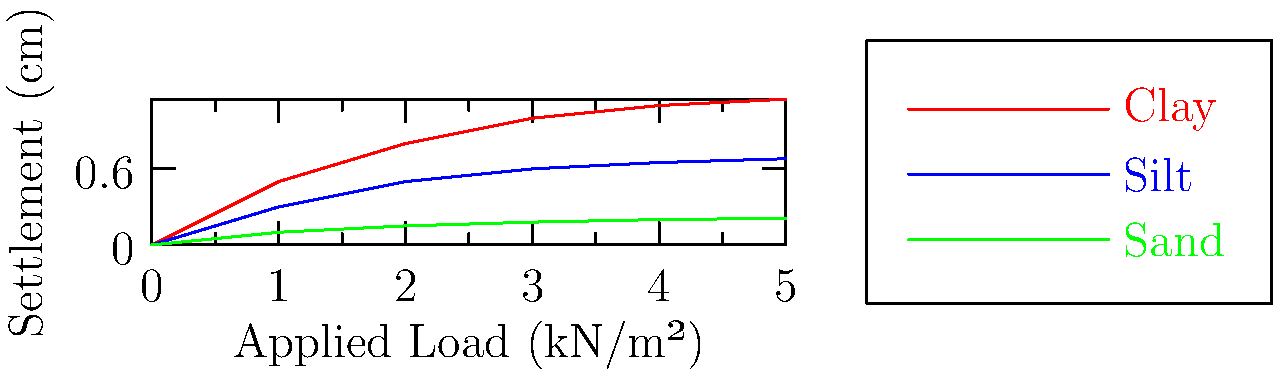A foundation is constructed on three different soil types: clay, silt, and sand. Based on the settlement curves shown in the graph, which soil type exhibits the highest settlement under an applied load of 3 kN/m²? Explain the factors contributing to the differences in settlement behavior among these soil types. To determine which soil type exhibits the highest settlement under an applied load of 3 kN/m², we need to analyze the graph and follow these steps:

1. Locate the applied load of 3 kN/m² on the x-axis.
2. Find the corresponding settlement values for each soil type at this load:
   - Clay (red line): approximately 1.0 cm
   - Silt (blue line): approximately 0.6 cm
   - Sand (green line): approximately 0.18 cm

3. Compare the settlement values:
   Clay (1.0 cm) > Silt (0.6 cm) > Sand (0.18 cm)

Therefore, clay exhibits the highest settlement under an applied load of 3 kN/m².

Factors contributing to the differences in settlement behavior:

1. Soil compressibility: Clay has the highest compressibility due to its plate-like particle structure and high water content, leading to more significant settlement.

2. Void ratio: Clay typically has a higher initial void ratio compared to silt and sand, allowing for more compression under load.

3. Drainage characteristics: 
   - Clay has poor drainage, leading to slower dissipation of excess pore water pressure and prolonged settlement.
   - Silt has moderate drainage, resulting in intermediate settlement behavior.
   - Sand has excellent drainage, allowing for quick dissipation of excess pore water pressure and minimal settlement.

4. Particle size and arrangement: 
   - Clay particles are fine and plate-like, allowing for more particle rearrangement under load.
   - Silt particles are intermediate in size and shape.
   - Sand particles are larger and more rounded, providing better interlocking and resistance to settlement.

5. Consolidation behavior: Clay undergoes significant consolidation over time, while sand experiences minimal consolidation due to its high permeability.

These factors combine to produce the observed settlement patterns, with clay showing the highest settlement, followed by silt, and then sand exhibiting the least settlement under the same applied load.
Answer: Clay exhibits the highest settlement (1.0 cm at 3 kN/m²) due to its high compressibility, poor drainage, and significant consolidation behavior. 